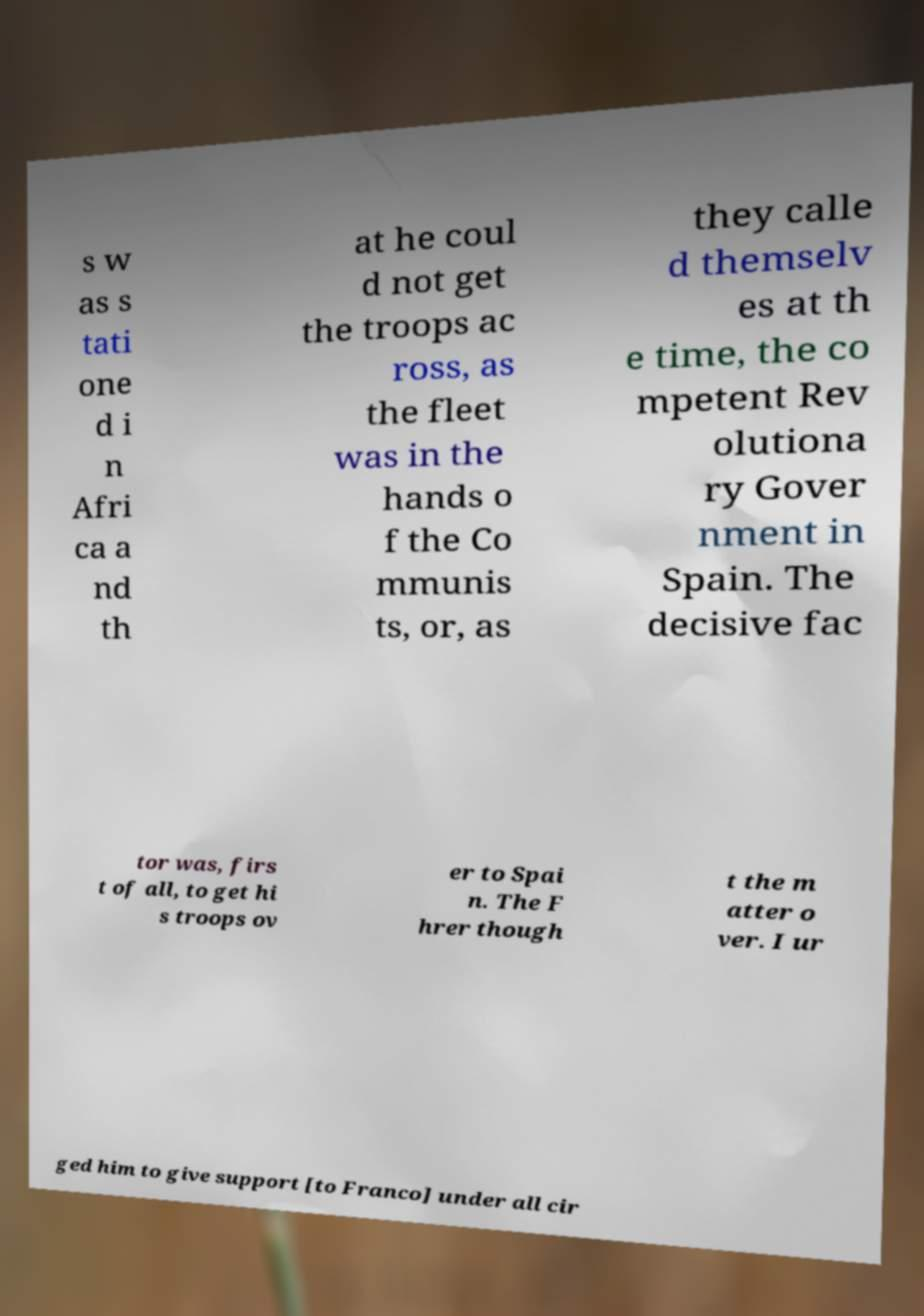Could you assist in decoding the text presented in this image and type it out clearly? s w as s tati one d i n Afri ca a nd th at he coul d not get the troops ac ross, as the fleet was in the hands o f the Co mmunis ts, or, as they calle d themselv es at th e time, the co mpetent Rev olutiona ry Gover nment in Spain. The decisive fac tor was, firs t of all, to get hi s troops ov er to Spai n. The F hrer though t the m atter o ver. I ur ged him to give support [to Franco] under all cir 